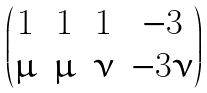<formula> <loc_0><loc_0><loc_500><loc_500>\begin{pmatrix} 1 & 1 & 1 & - 3 \\ \mu & \mu & \nu & - 3 \nu \end{pmatrix}</formula> 